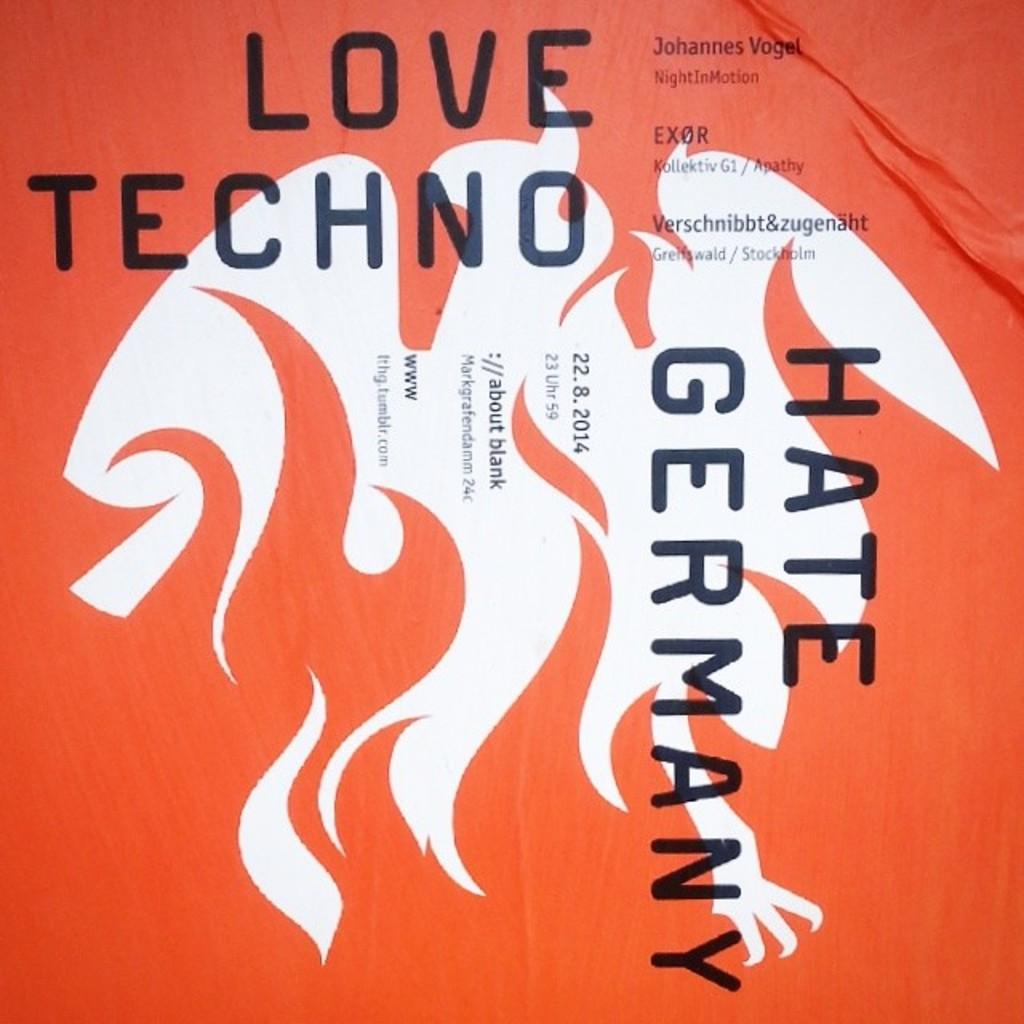<image>
Write a terse but informative summary of the picture. a flamed picture with the word hate on it 